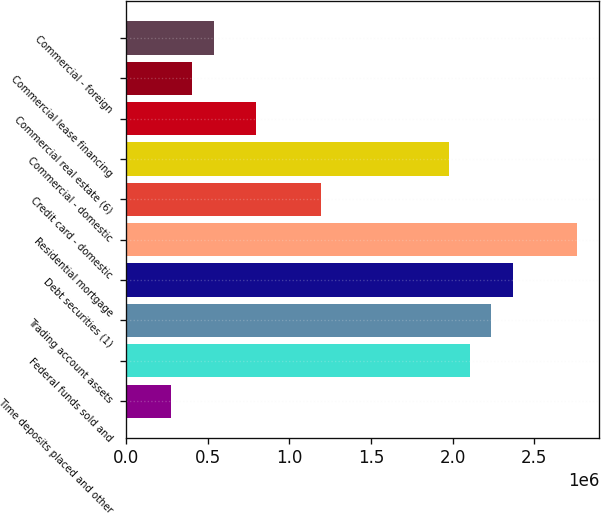Convert chart. <chart><loc_0><loc_0><loc_500><loc_500><bar_chart><fcel>Time deposits placed and other<fcel>Federal funds sold and<fcel>Trading account assets<fcel>Debt securities (1)<fcel>Residential mortgage<fcel>Credit card - domestic<fcel>Commercial - domestic<fcel>Commercial real estate (6)<fcel>Commercial lease financing<fcel>Commercial - foreign<nl><fcel>275090<fcel>2.10709e+06<fcel>2.23794e+06<fcel>2.3688e+06<fcel>2.76137e+06<fcel>1.19109e+06<fcel>1.97623e+06<fcel>798518<fcel>405947<fcel>536804<nl></chart> 